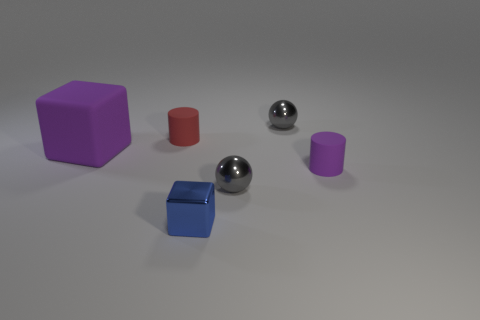Are there any other things that have the same size as the red matte thing?
Provide a short and direct response. Yes. What is the material of the blue block that is on the left side of the tiny purple matte thing?
Your response must be concise. Metal. What material is the tiny blue object?
Offer a terse response. Metal. There is a tiny gray ball in front of the small red object that is on the left side of the cube right of the purple block; what is it made of?
Ensure brevity in your answer.  Metal. Do the purple matte cylinder and the sphere that is in front of the tiny red cylinder have the same size?
Provide a succinct answer. Yes. What number of things are either objects that are behind the small blue metallic object or large rubber cubes behind the small purple rubber cylinder?
Your response must be concise. 5. What is the color of the rubber thing that is to the right of the blue metallic cube?
Give a very brief answer. Purple. There is a purple cylinder in front of the small red thing; are there any small balls that are in front of it?
Your response must be concise. Yes. Is the number of tiny blue things less than the number of metal things?
Give a very brief answer. Yes. What is the material of the big purple object that is behind the cube that is in front of the matte block?
Offer a very short reply. Rubber. 